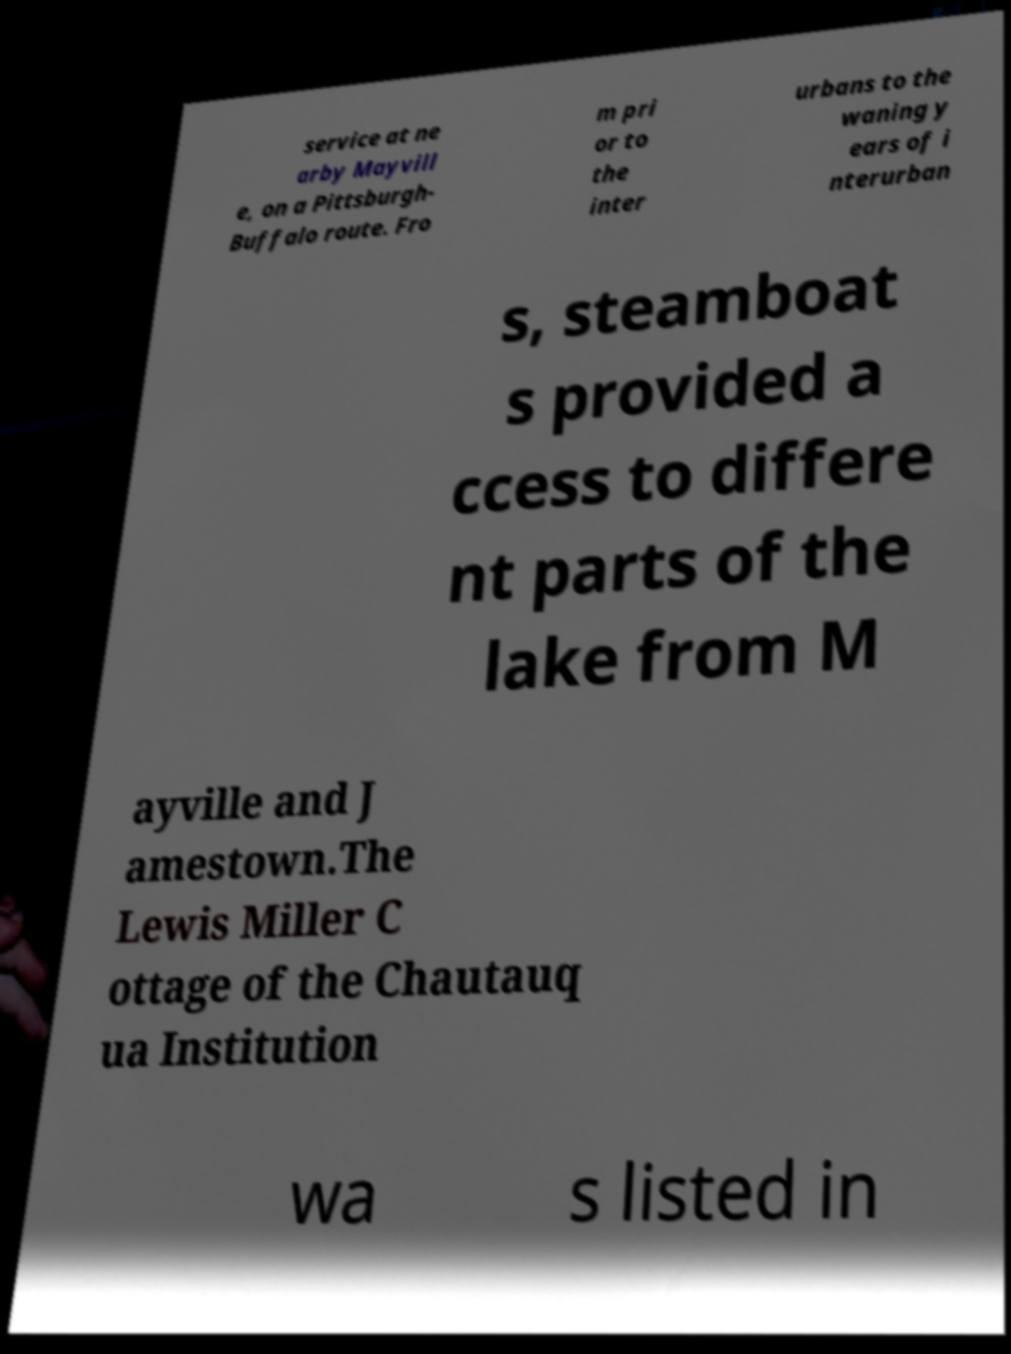I need the written content from this picture converted into text. Can you do that? service at ne arby Mayvill e, on a Pittsburgh- Buffalo route. Fro m pri or to the inter urbans to the waning y ears of i nterurban s, steamboat s provided a ccess to differe nt parts of the lake from M ayville and J amestown.The Lewis Miller C ottage of the Chautauq ua Institution wa s listed in 